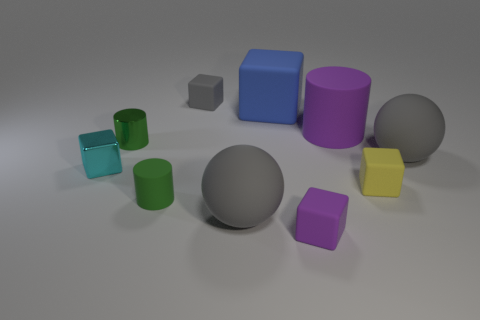How many tiny red cylinders are made of the same material as the small purple thing? Upon examining the image, I don't see any tiny red cylinders present at all, which means the answer to the question is zero. However, if we're discussing materials and comparing other objects, it's important to note that with the image provided, I cannot verify the material composition of the objects, but based on appearances, the small purple cube may be made of plastic, similar to the other colorful, opaque objects in the scene. 